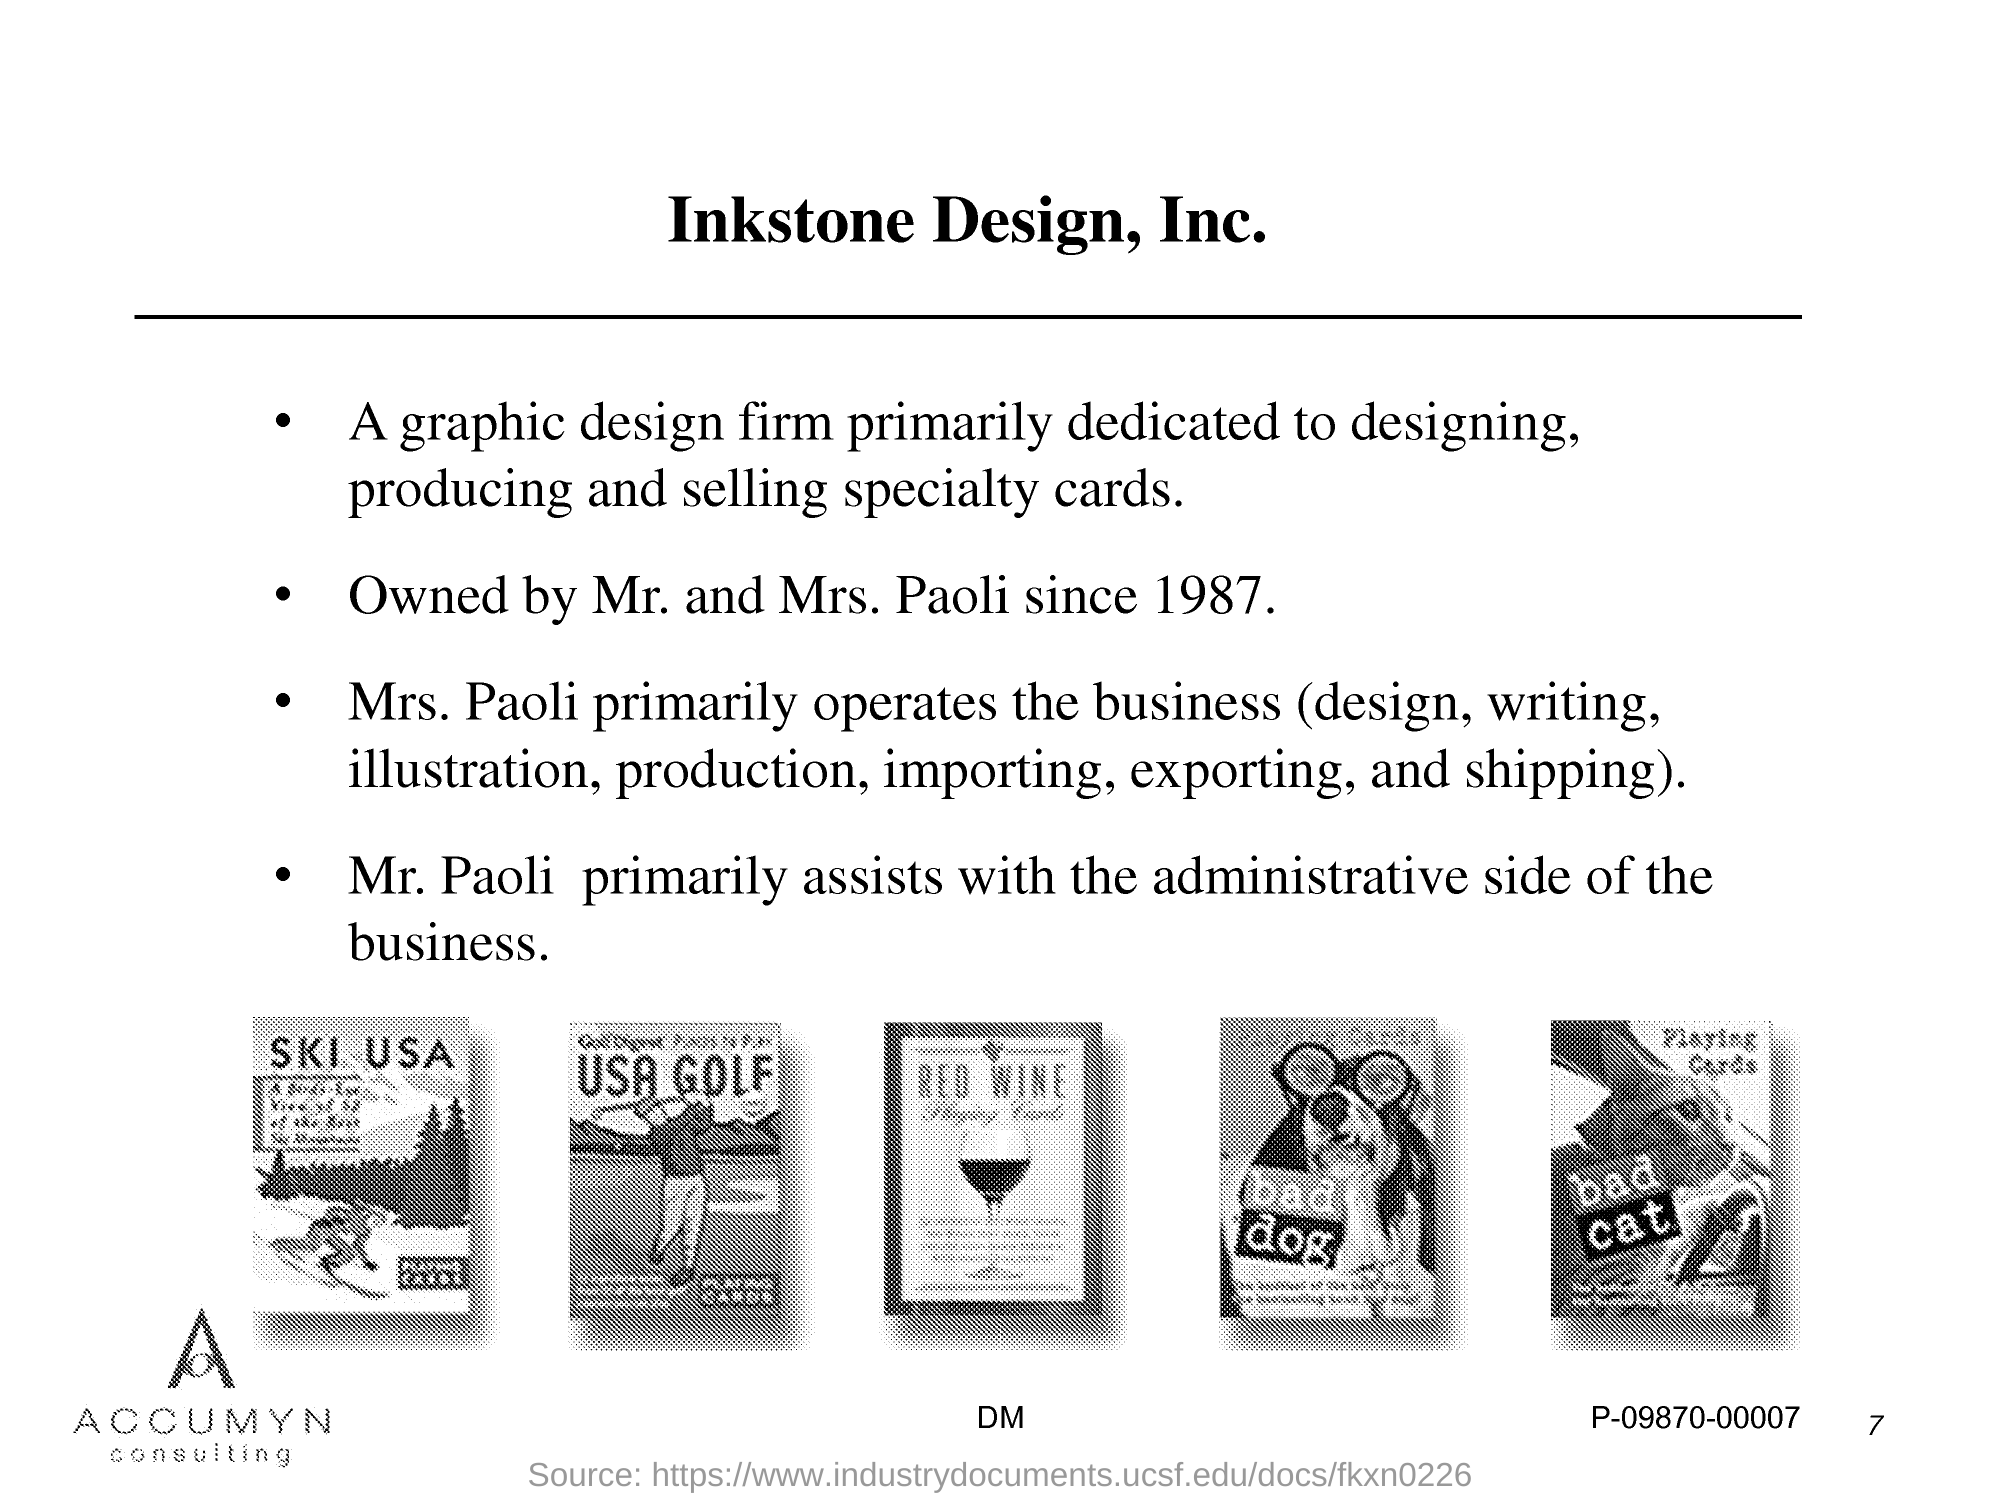Highlight a few significant elements in this photo. Seven is the page number. 